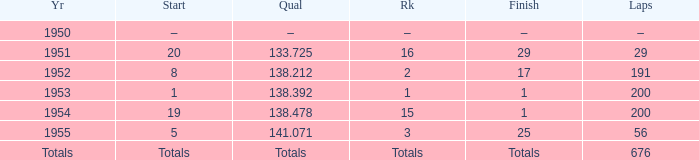What year was the ranking 1? 1953.0. 